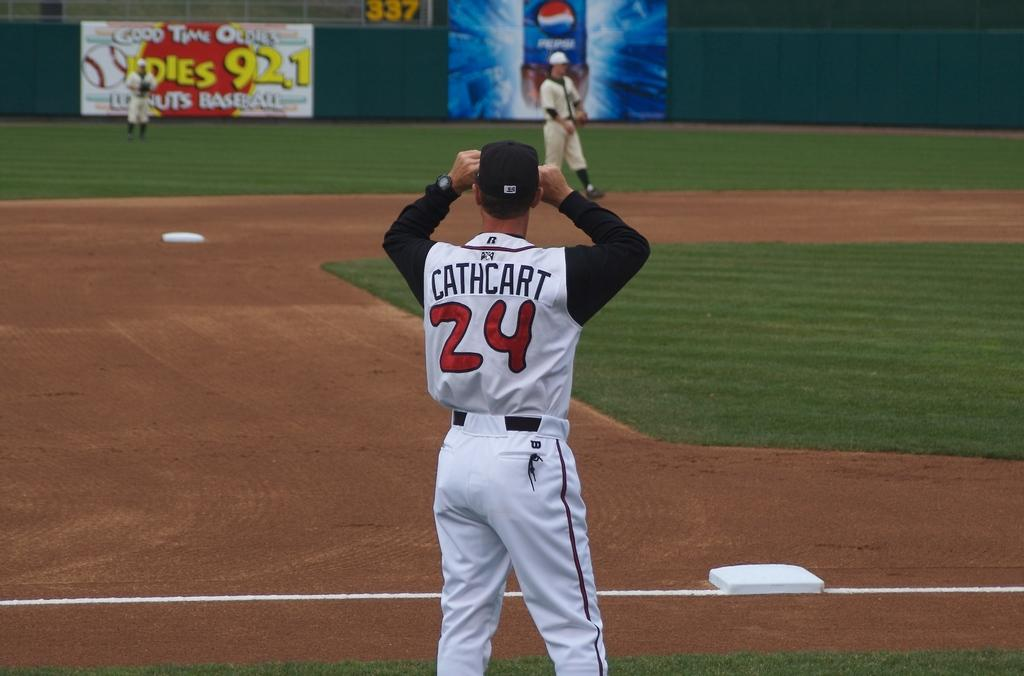Provide a one-sentence caption for the provided image. Number 24 Cathcart waiting for a ball at a basball game. 